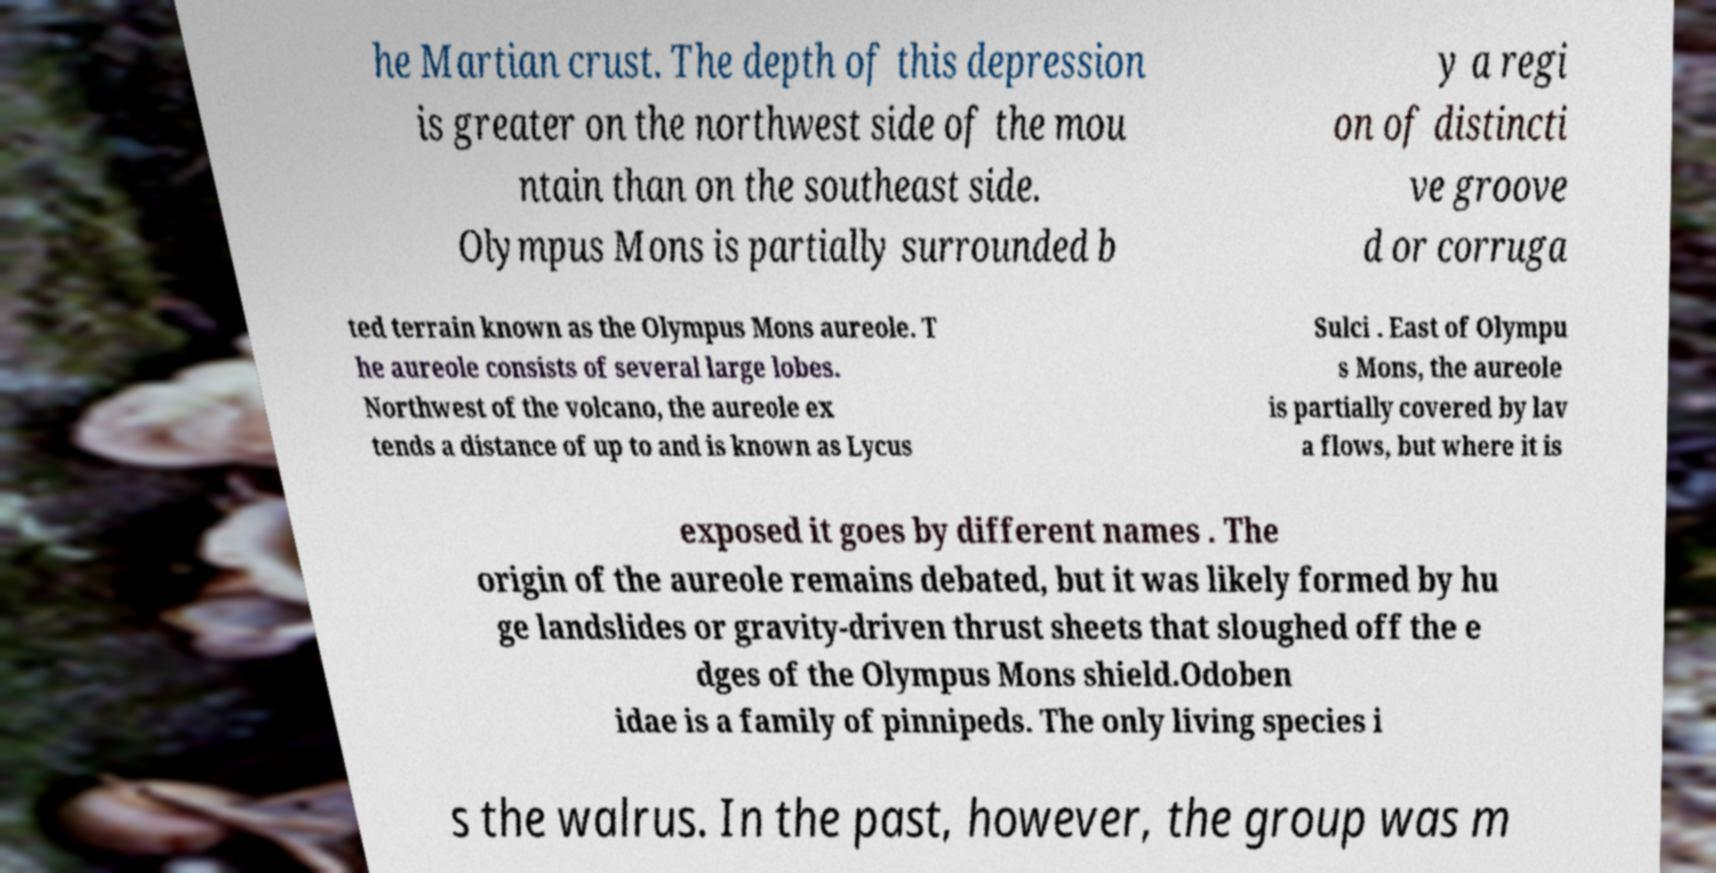For documentation purposes, I need the text within this image transcribed. Could you provide that? he Martian crust. The depth of this depression is greater on the northwest side of the mou ntain than on the southeast side. Olympus Mons is partially surrounded b y a regi on of distincti ve groove d or corruga ted terrain known as the Olympus Mons aureole. T he aureole consists of several large lobes. Northwest of the volcano, the aureole ex tends a distance of up to and is known as Lycus Sulci . East of Olympu s Mons, the aureole is partially covered by lav a flows, but where it is exposed it goes by different names . The origin of the aureole remains debated, but it was likely formed by hu ge landslides or gravity-driven thrust sheets that sloughed off the e dges of the Olympus Mons shield.Odoben idae is a family of pinnipeds. The only living species i s the walrus. In the past, however, the group was m 